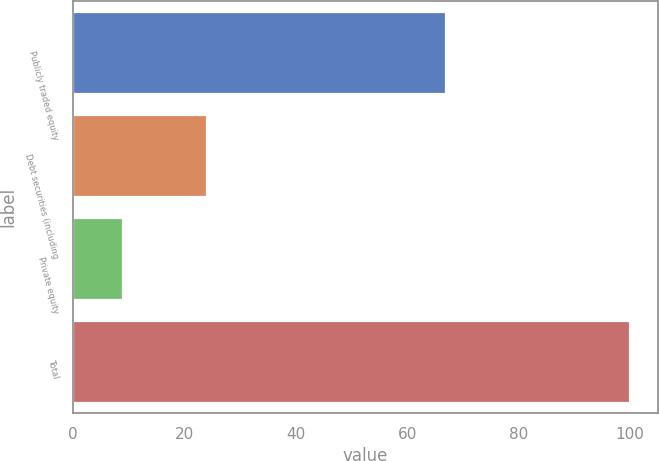Convert chart to OTSL. <chart><loc_0><loc_0><loc_500><loc_500><bar_chart><fcel>Publicly traded equity<fcel>Debt securities (including<fcel>Private equity<fcel>Total<nl><fcel>67<fcel>24<fcel>9<fcel>100<nl></chart> 